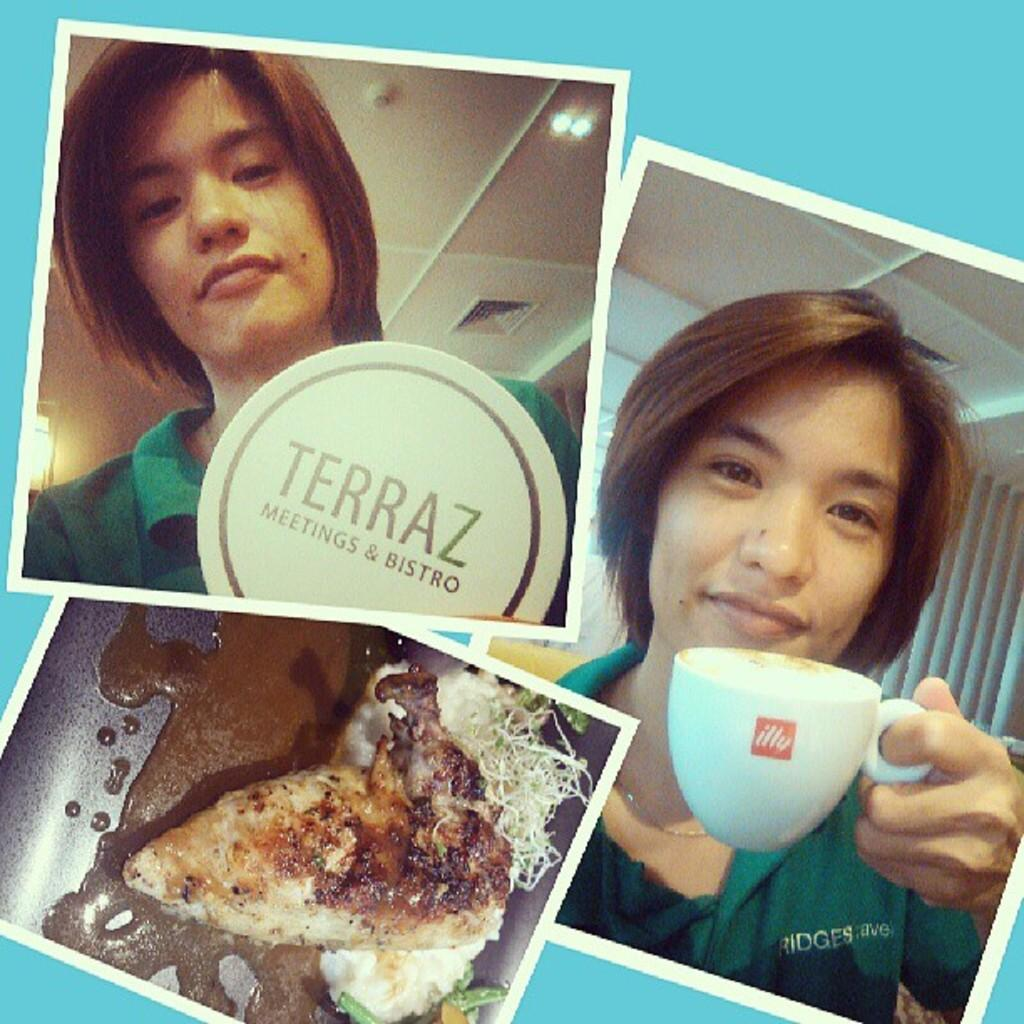What type of artwork is depicted in the image? The image is a collage. What subjects are included in the collage? The collage contains images of persons and food. What type of cushion is featured in the image? There is no cushion present in the image; it contains images of persons and food in a collage. 